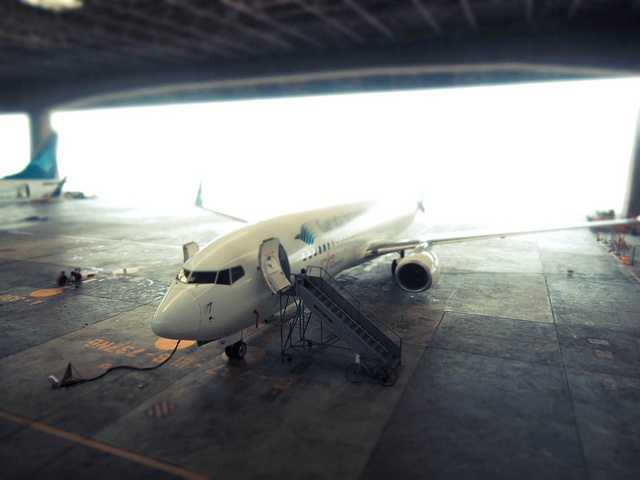Describe the objects in this image and their specific colors. I can see airplane in black, ivory, gray, and darkgray tones, airplane in black, darkgray, teal, and lightgray tones, people in black and gray tones, and people in black, gray, and brown tones in this image. 